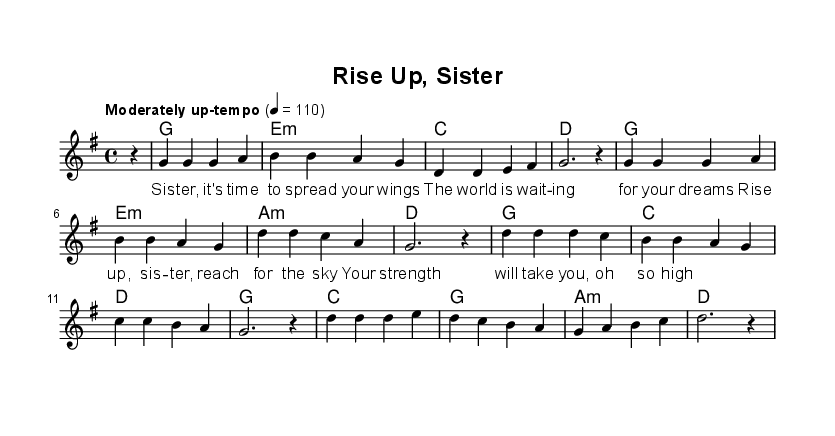What is the key signature of this music? The key signature is G major, which has one sharp (F#). This can be identified from the initial key signature notation after "global" in the code.
Answer: G major What is the time signature of this music? The time signature is 4/4, indicated immediately after the key signature in the same "global" section. This means there are four beats per measure, and the quarter note gets one beat.
Answer: 4/4 What is the tempo marking of this piece? The tempo marking is "Moderately up-tempo," set to 110 beats per minute, as indicated in the "global" section.
Answer: Moderately up-tempo How many distinct sections are present in this music? The piece contains three distinct sections: an introduction, a verse, and a chorus. This is observed by the separate melodic lines and lyrics provided for the verse and chorus.
Answer: 3 What is the first chord in the harmony? The first chord in the harmony is G, seen at the beginning of the "harmonies" section where the chord is written as "g1".
Answer: G What lyrical theme is emphasized in the chorus of the song? The lyrical theme emphasizes empowerment and aspiration, as shown in the lyrics of the chorus, urging the sister to rise and reach for the sky. It reflects the message of strength and ambition, common in empowering soul music.
Answer: Empowerment 